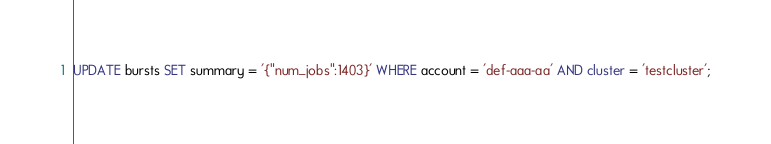<code> <loc_0><loc_0><loc_500><loc_500><_SQL_>UPDATE bursts SET summary = '{"num_jobs":1403}' WHERE account = 'def-aaa-aa' AND cluster = 'testcluster';
</code> 